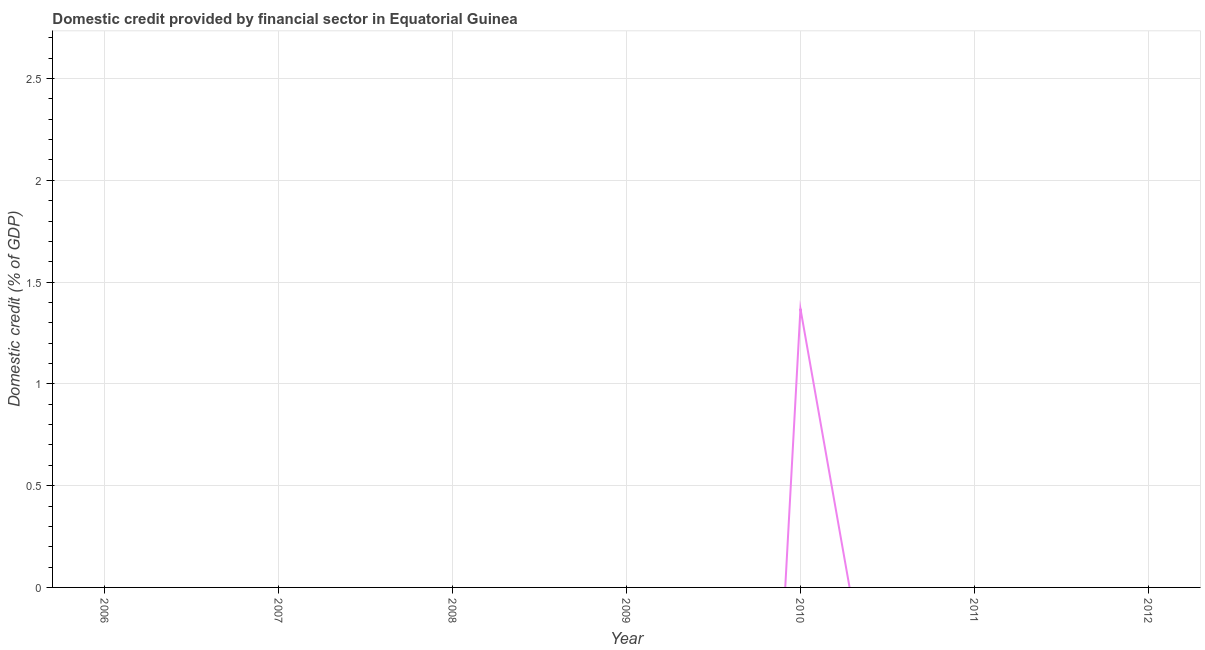What is the domestic credit provided by financial sector in 2006?
Ensure brevity in your answer.  0. Across all years, what is the maximum domestic credit provided by financial sector?
Give a very brief answer. 1.37. What is the sum of the domestic credit provided by financial sector?
Make the answer very short. 1.37. What is the average domestic credit provided by financial sector per year?
Your answer should be very brief. 0.2. What is the difference between the highest and the lowest domestic credit provided by financial sector?
Offer a very short reply. 1.37. Does the domestic credit provided by financial sector monotonically increase over the years?
Offer a terse response. No. How many lines are there?
Provide a short and direct response. 1. How many years are there in the graph?
Keep it short and to the point. 7. Are the values on the major ticks of Y-axis written in scientific E-notation?
Your answer should be very brief. No. Does the graph contain grids?
Offer a terse response. Yes. What is the title of the graph?
Make the answer very short. Domestic credit provided by financial sector in Equatorial Guinea. What is the label or title of the X-axis?
Give a very brief answer. Year. What is the label or title of the Y-axis?
Provide a succinct answer. Domestic credit (% of GDP). What is the Domestic credit (% of GDP) of 2008?
Your response must be concise. 0. What is the Domestic credit (% of GDP) in 2010?
Make the answer very short. 1.37. What is the Domestic credit (% of GDP) of 2011?
Provide a succinct answer. 0. 